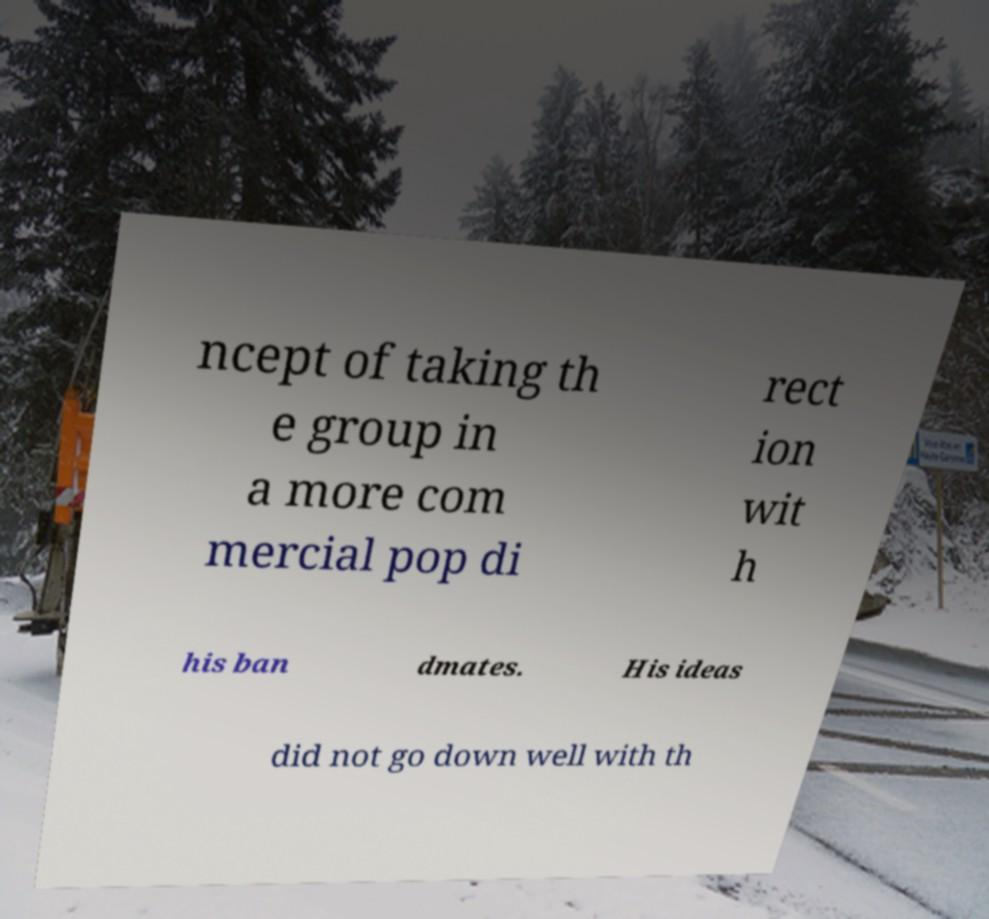I need the written content from this picture converted into text. Can you do that? ncept of taking th e group in a more com mercial pop di rect ion wit h his ban dmates. His ideas did not go down well with th 